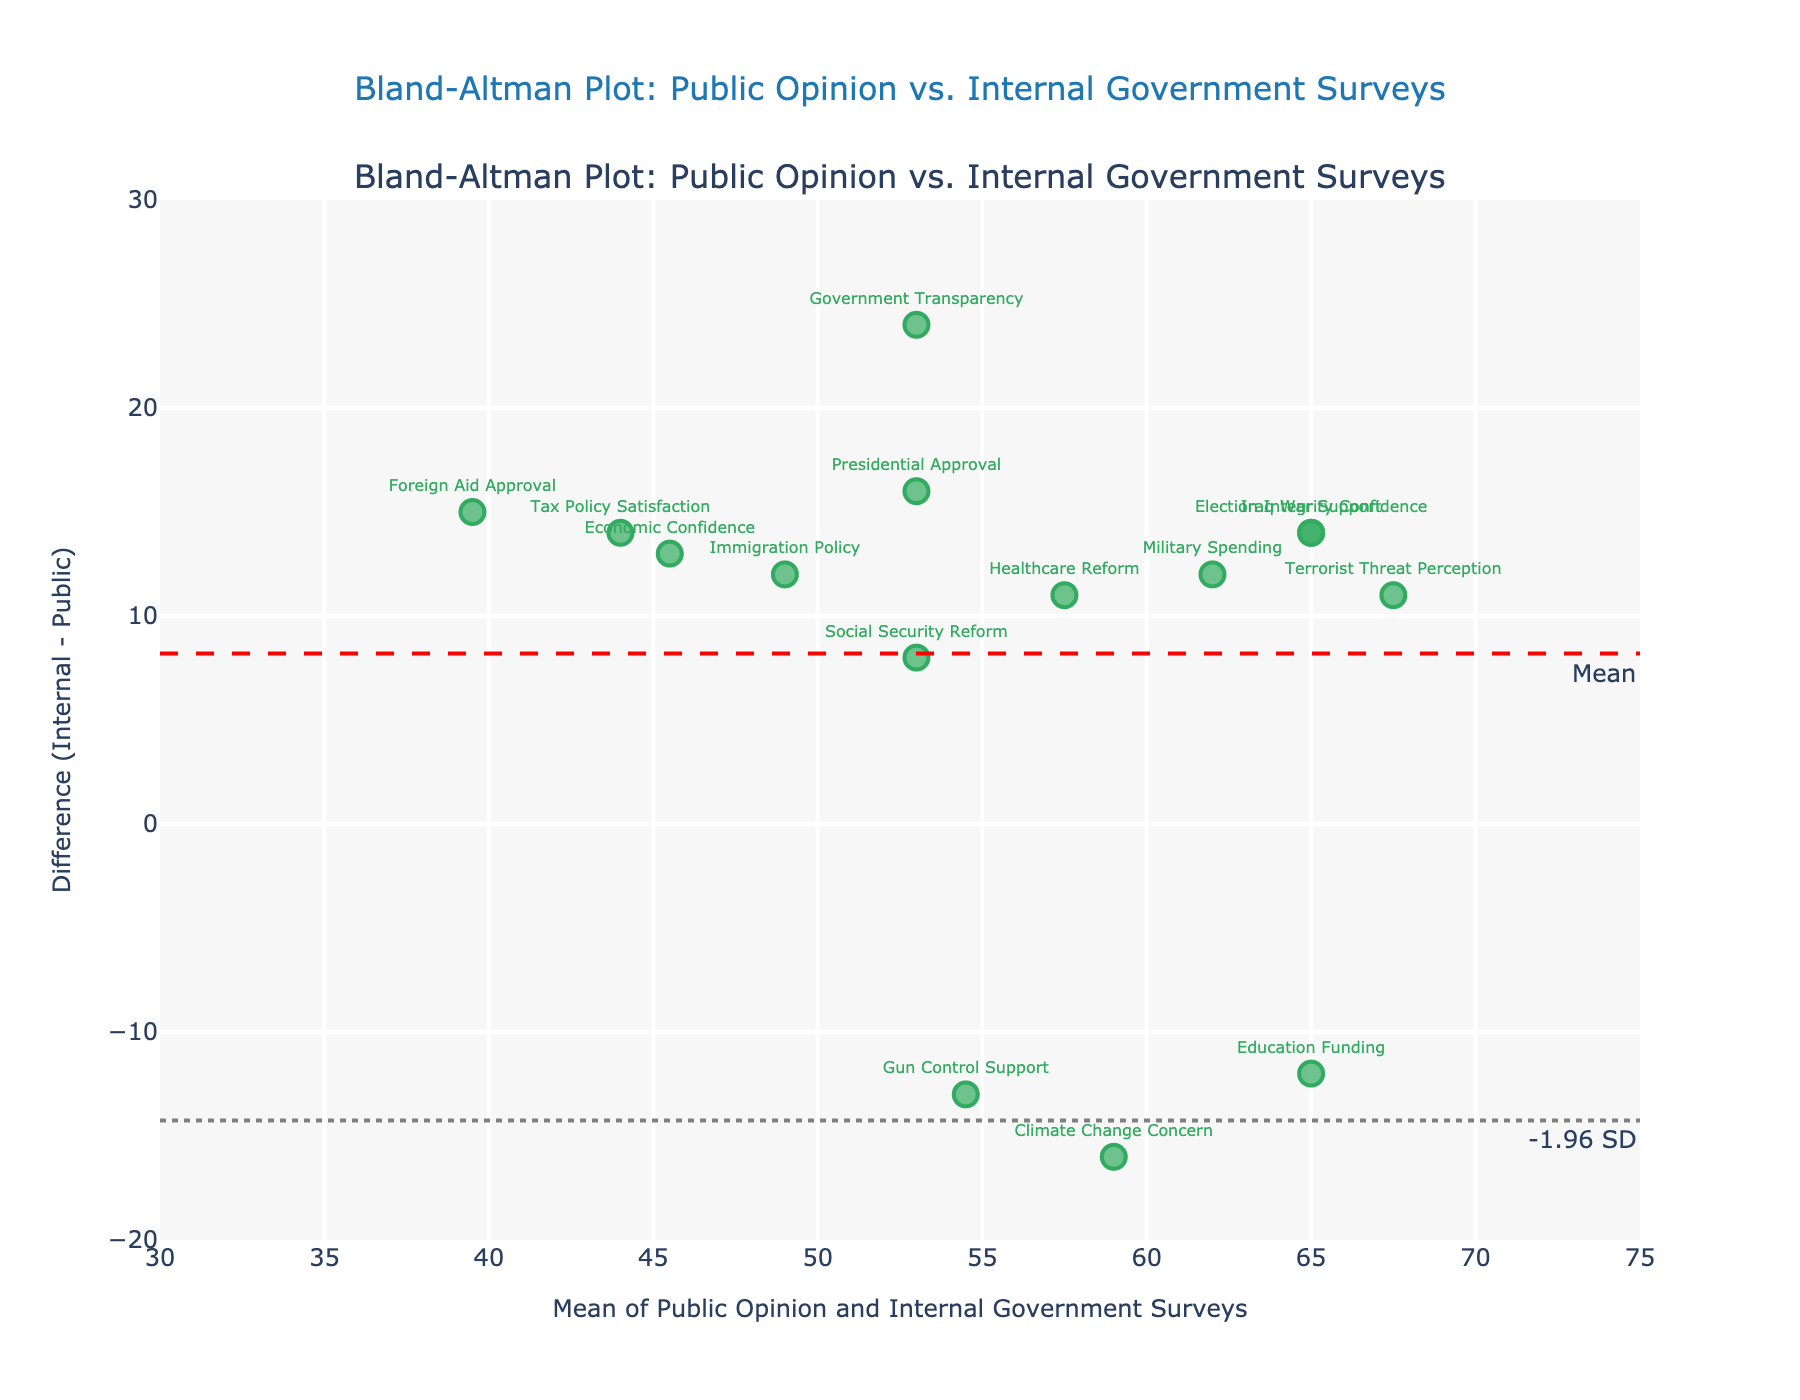What is the title of the Bland-Altman plot? The title of the plot is written at the top and centers with larger font size and blue color. The exact wording is "Bland-Altman Plot: Public Opinion vs. Internal Government Surveys".
Answer: Bland-Altman Plot: Public Opinion vs. Internal Government Surveys What colors are used for the data points in the plot? The data points are represented in green color with slight transparency and black outlines. These points also have text labels above them.
Answer: Green and black How many data points are there on the plot? Each data point corresponds to a different political issue, which can be counted by either the green markers or the methods listed on the plot. By counting the markers, we note there are 15 data points.
Answer: 15 What does the red dash line on the plot represent? The red dash line passes horizontally through the plot. Its annotation indicates it represents the mean difference between the Internal Government Surveys and Public Opinion Polls.
Answer: Mean difference What are the values of the upper and lower limits of agreement? The upper and lower limits of agreement are represented by gray dot lines. To read their values, we look at where these lines intersect the y-axis, which are annotated as "+1.96 SD" and "-1.96 SD" respectively.
Answer: Approximately 19.24 and -17.73 Which political issue shows the largest discrepancy (positive difference) between internal government surveys and public opinion polls? The discrepancy or difference between internal government surveys and public opinion polls for each issue can be observed by looking at the vertical distance from the x-axis. The issue with the highest positive difference is annotated at the "Terrorist Threat Perception" point.
Answer: Terrorist Threat Perception Is there any political issue that shows almost no discrepancy between public opinion polls and internal government surveys? To understand discrepancy, we look for any data point that lies close to the y=0 line which means nearly no difference. The closest point appears to be around the "Social Security Reform" value.
Answer: Social Security Reform What is the range of mean values on the x-axis? The x-axis represents the average of both survey types for each issue. By checking the range from the smallest to the largest mean value shown on the x-axis, it spans from approximately 30 to 75.
Answer: Approximately 30 to 75 